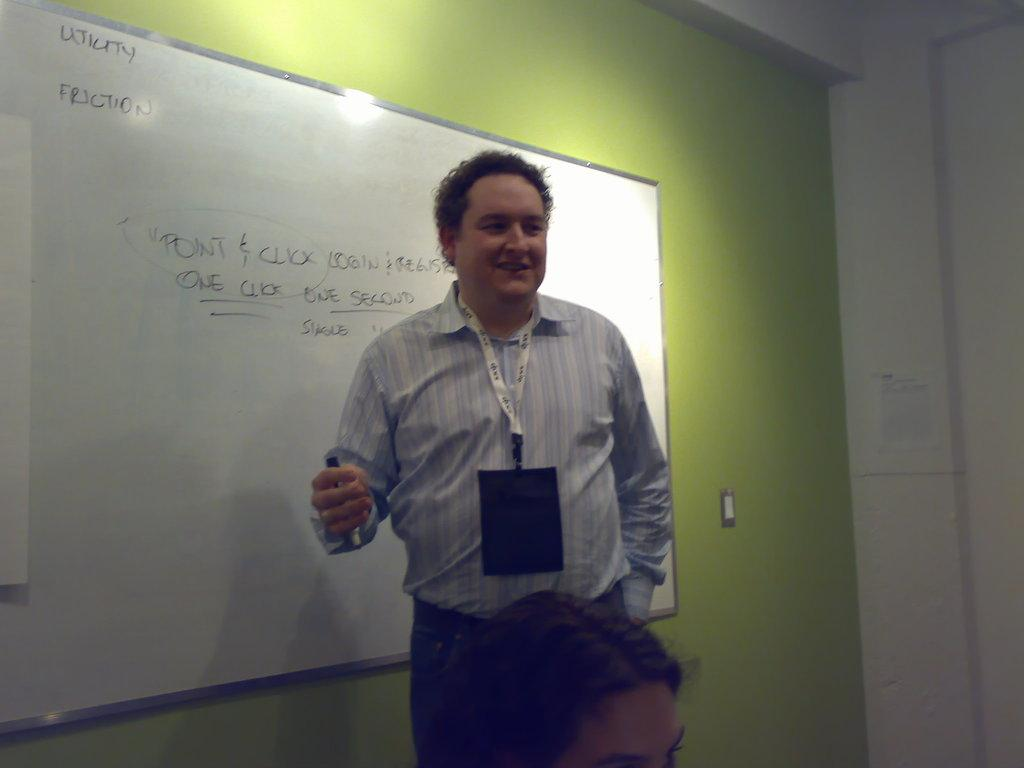<image>
Render a clear and concise summary of the photo. A man with a lanyard is speaking in the front of a room with a whiteboard that says Utility Friction. 